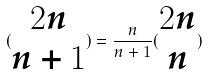Convert formula to latex. <formula><loc_0><loc_0><loc_500><loc_500>( \begin{matrix} 2 n \\ n + 1 \end{matrix} ) = \frac { n } { n + 1 } ( \begin{matrix} 2 n \\ n \end{matrix} )</formula> 